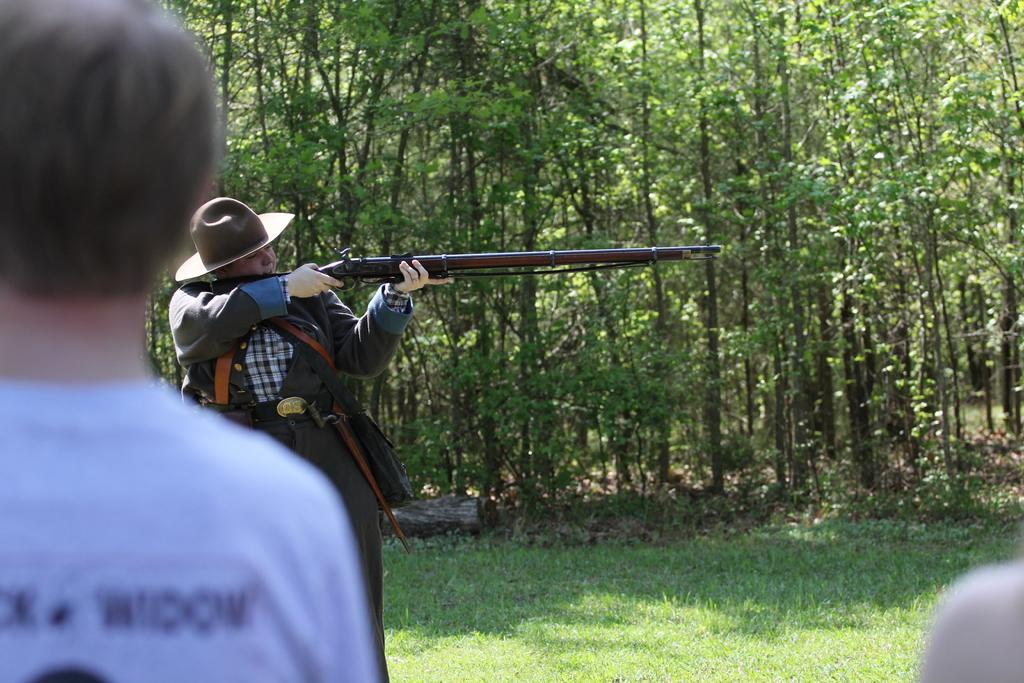What is the person in the image holding? The person in the image is holding a gun. What can be seen in the background of the image? There are trees in the background of the image. Who is the person standing in the front of the image? There is a man standing in the front of the image. What type of bed can be seen in the image? There is no bed present in the image. What role does the person holding the gun play in relation to the man standing in the front? The provided facts do not give any information about the relationship between the person holding the gun and the man standing in the front. --- Facts: 1. There is a person sitting on a chair in the image. 2. The person is holding a book. 3. There is a table next to the chair. 4. There is a lamp on the table. 5. The room has a wooden floor. Absurd Topics: ocean, parrot, bicycle Conversation: What is the person in the image doing? The person in the image is sitting on a chair. What is the person holding while sitting on the chair? The person is holding a book. What is located next to the chair? There is a table next to the chair. What object is on the table? There is a lamp on the table. What type of flooring is present in the room? The room has a wooden floor. Reasoning: Let's think step by step in order to produce the conversation. We start by identifying the main subject in the image, which is the person sitting on a chair. Then, we expand the conversation to include other elements of the image, such as the book, table, lamp, and wooden floor. Each question is designed to elicit a specific detail about the image that is known from the provided facts. Absurd Question/Answer: Can you see any ocean waves in the image? There is no ocean or waves present in the image. Is there a parrot sitting on the person's shoulder in the image? There is no parrot present in the image. 